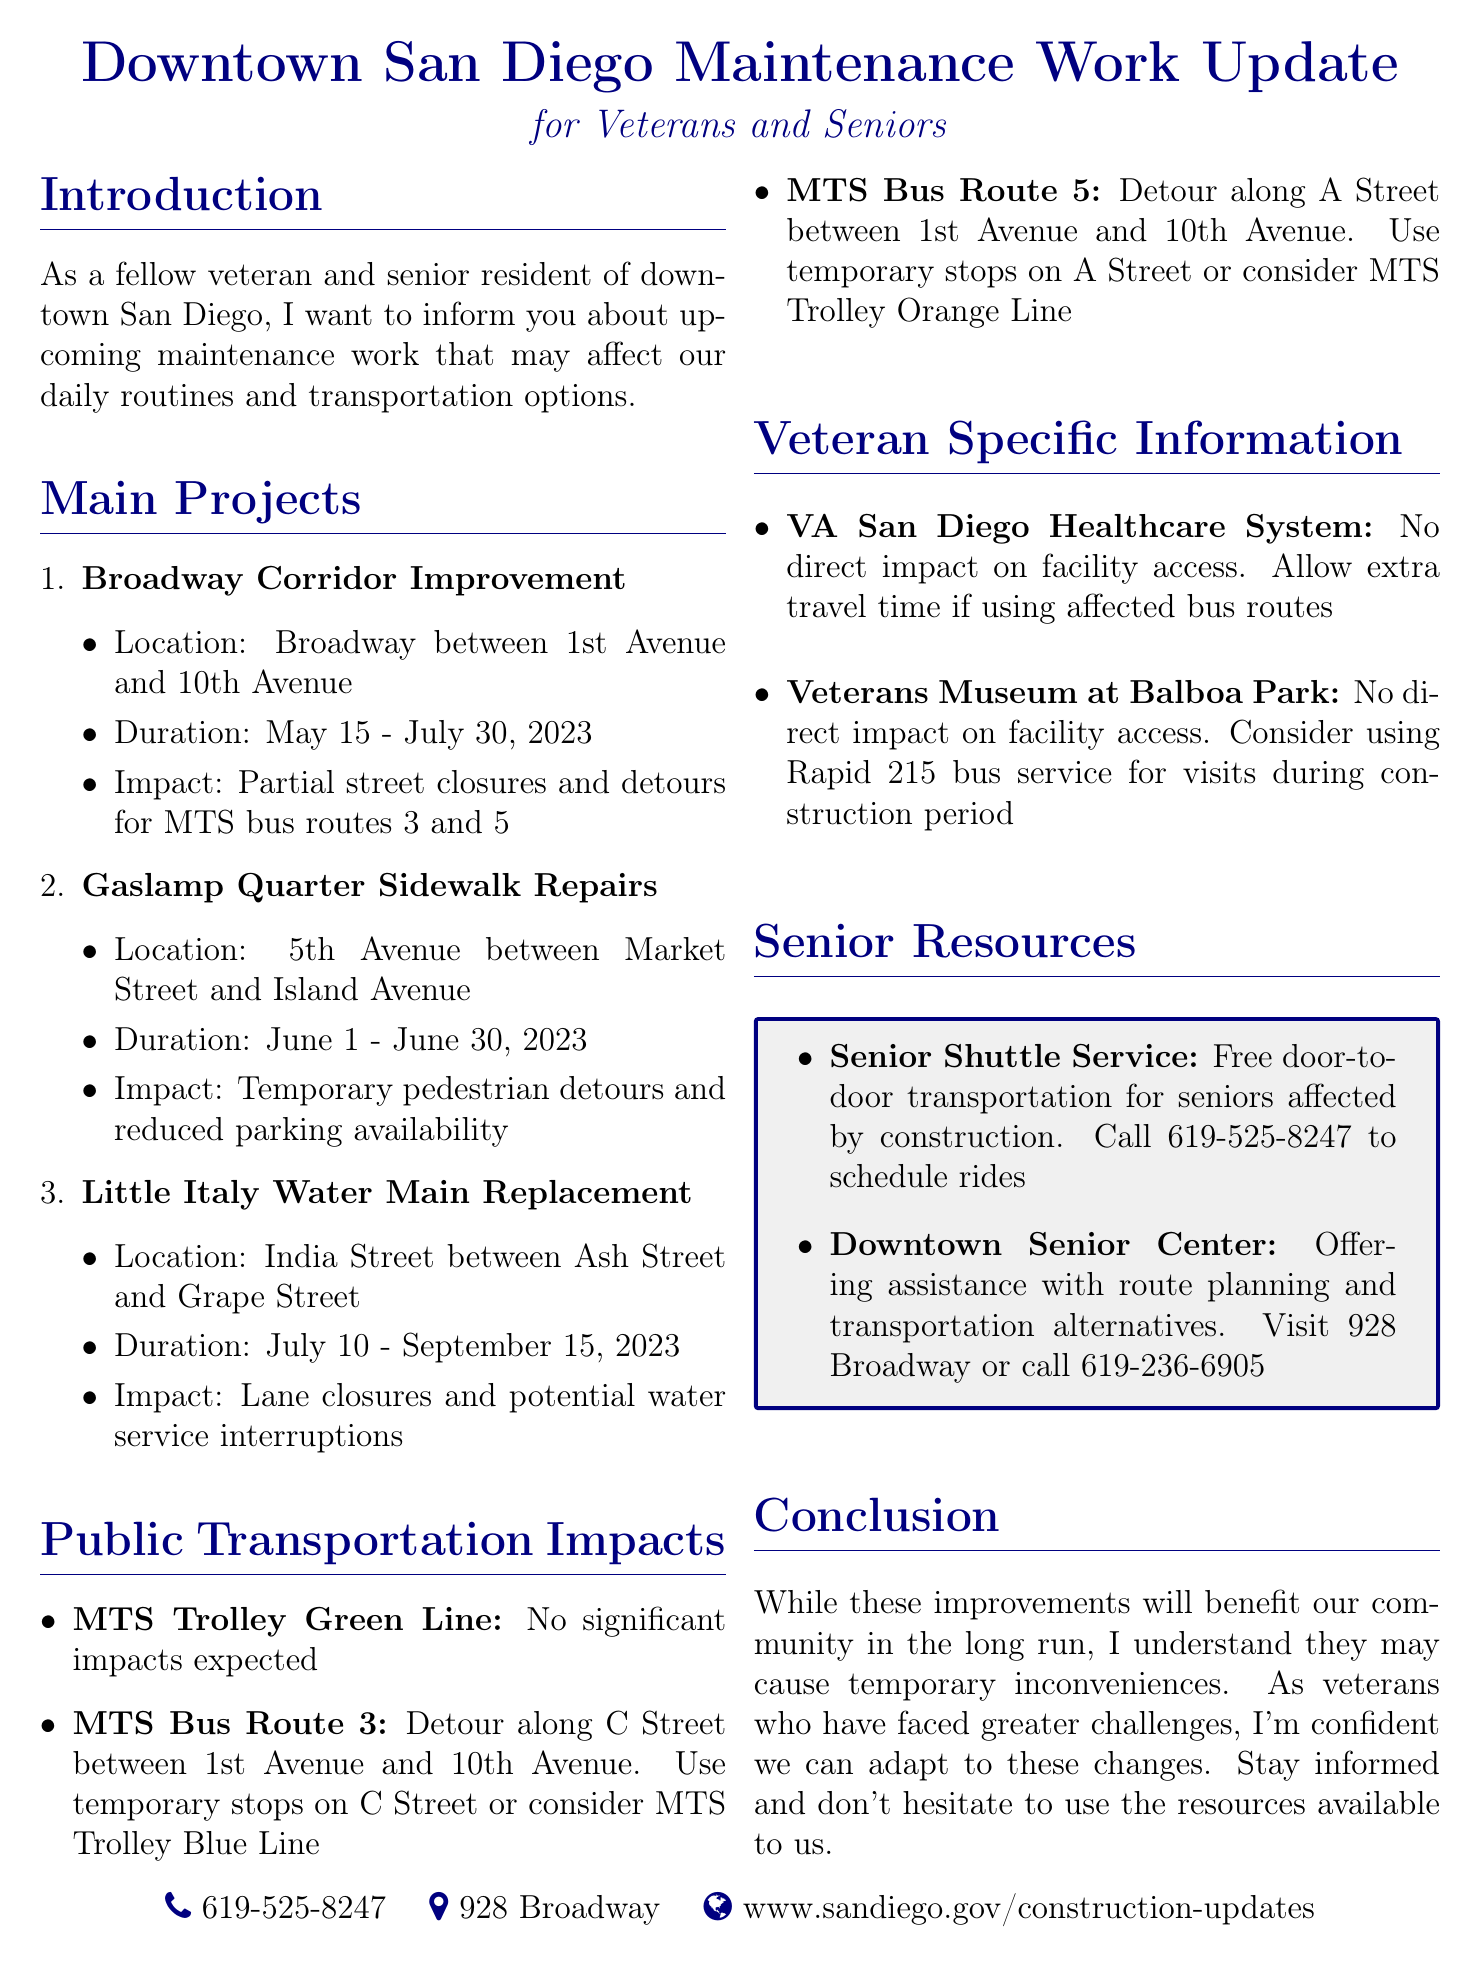What is the title of the memo? The title is explicitly stated at the beginning of the document.
Answer: Downtown San Diego Maintenance Work Update for Veterans and Seniors What is the location of the Broadway Corridor Improvement project? The location is mentioned alongside each project in the main projects section.
Answer: Broadway between 1st Avenue and 10th Avenue What is the duration of the Gaslamp Quarter Sidewalk Repairs? The duration is provided in the details for each project.
Answer: June 1 - June 30, 2023 Which bus route has a detour along C Street? This information can be found under the public transportation impacts section.
Answer: MTS Bus Route 3 What type of resource is the Senior Shuttle Service? The document mentions various services available to seniors.
Answer: Free door-to-door transportation What is the contact number for scheduling rides with the Senior Shuttle Service? This detail is specifically listed under senior resources.
Answer: 619-525-8247 Is there a significant impact expected on the MTS Trolley Green Line? The expected impact is mentioned for each public transportation route.
Answer: No Which service should veterans consider for visits to the Veterans Museum during construction? This note is provided in the veteran specific information section.
Answer: Rapid 215 bus service What should seniors do if they need assistance with route planning? The document offers options for seniors; this context is given in the senior resources section.
Answer: Visit 928 Broadway or call 619-236-6905 